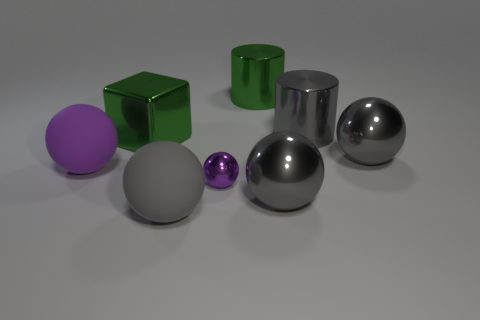Could you describe the lighting and shadows seen in the image? The lighting in the image seems to come from the upper right, as indicated by the highlights on the objects and the shadows they cast to their left. There is a soft diffuse light creating subtle shadows, hinting at either an overcast external light source or a softbox used in indoor photography. The shadows have soft edges, which imply the light source is not overly harsh or direct. 